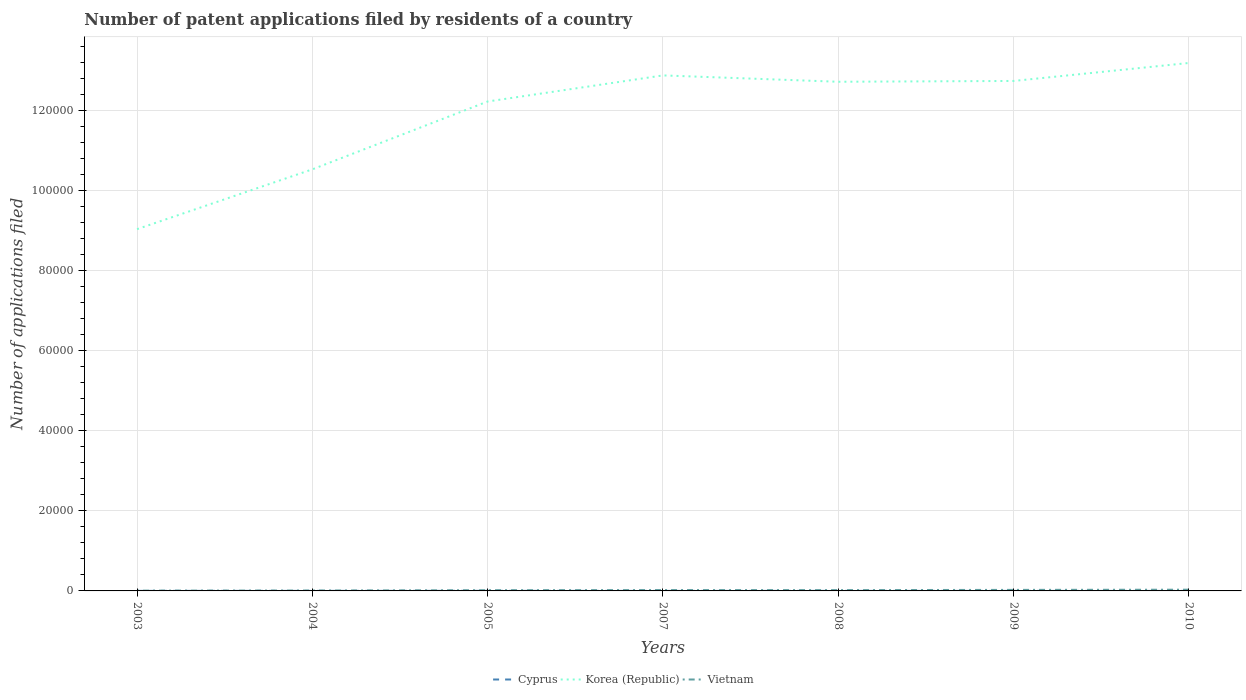Does the line corresponding to Vietnam intersect with the line corresponding to Cyprus?
Keep it short and to the point. No. Is the number of lines equal to the number of legend labels?
Ensure brevity in your answer.  Yes. Across all years, what is the maximum number of applications filed in Korea (Republic)?
Your response must be concise. 9.03e+04. What is the difference between the highest and the second highest number of applications filed in Cyprus?
Give a very brief answer. 17. What is the difference between the highest and the lowest number of applications filed in Cyprus?
Your answer should be compact. 3. How many lines are there?
Offer a terse response. 3. How are the legend labels stacked?
Provide a short and direct response. Horizontal. What is the title of the graph?
Offer a terse response. Number of patent applications filed by residents of a country. What is the label or title of the X-axis?
Your answer should be very brief. Years. What is the label or title of the Y-axis?
Make the answer very short. Number of applications filed. What is the Number of applications filed of Cyprus in 2003?
Provide a short and direct response. 12. What is the Number of applications filed of Korea (Republic) in 2003?
Give a very brief answer. 9.03e+04. What is the Number of applications filed of Cyprus in 2004?
Offer a terse response. 9. What is the Number of applications filed of Korea (Republic) in 2004?
Make the answer very short. 1.05e+05. What is the Number of applications filed in Vietnam in 2004?
Offer a terse response. 103. What is the Number of applications filed in Cyprus in 2005?
Give a very brief answer. 20. What is the Number of applications filed in Korea (Republic) in 2005?
Make the answer very short. 1.22e+05. What is the Number of applications filed of Vietnam in 2005?
Give a very brief answer. 180. What is the Number of applications filed in Cyprus in 2007?
Provide a short and direct response. 3. What is the Number of applications filed in Korea (Republic) in 2007?
Provide a short and direct response. 1.29e+05. What is the Number of applications filed in Vietnam in 2007?
Your answer should be compact. 219. What is the Number of applications filed of Cyprus in 2008?
Ensure brevity in your answer.  11. What is the Number of applications filed of Korea (Republic) in 2008?
Make the answer very short. 1.27e+05. What is the Number of applications filed in Vietnam in 2008?
Keep it short and to the point. 204. What is the Number of applications filed of Korea (Republic) in 2009?
Provide a succinct answer. 1.27e+05. What is the Number of applications filed in Vietnam in 2009?
Your answer should be compact. 258. What is the Number of applications filed of Korea (Republic) in 2010?
Your answer should be compact. 1.32e+05. What is the Number of applications filed in Vietnam in 2010?
Ensure brevity in your answer.  306. Across all years, what is the maximum Number of applications filed in Cyprus?
Your response must be concise. 20. Across all years, what is the maximum Number of applications filed of Korea (Republic)?
Provide a short and direct response. 1.32e+05. Across all years, what is the maximum Number of applications filed of Vietnam?
Give a very brief answer. 306. Across all years, what is the minimum Number of applications filed in Korea (Republic)?
Your answer should be compact. 9.03e+04. Across all years, what is the minimum Number of applications filed in Vietnam?
Offer a terse response. 78. What is the total Number of applications filed in Cyprus in the graph?
Your answer should be compact. 65. What is the total Number of applications filed in Korea (Republic) in the graph?
Ensure brevity in your answer.  8.33e+05. What is the total Number of applications filed of Vietnam in the graph?
Give a very brief answer. 1348. What is the difference between the Number of applications filed of Cyprus in 2003 and that in 2004?
Offer a terse response. 3. What is the difference between the Number of applications filed of Korea (Republic) in 2003 and that in 2004?
Offer a very short reply. -1.49e+04. What is the difference between the Number of applications filed of Korea (Republic) in 2003 and that in 2005?
Keep it short and to the point. -3.19e+04. What is the difference between the Number of applications filed of Vietnam in 2003 and that in 2005?
Give a very brief answer. -102. What is the difference between the Number of applications filed of Cyprus in 2003 and that in 2007?
Provide a short and direct response. 9. What is the difference between the Number of applications filed of Korea (Republic) in 2003 and that in 2007?
Your response must be concise. -3.84e+04. What is the difference between the Number of applications filed of Vietnam in 2003 and that in 2007?
Your answer should be compact. -141. What is the difference between the Number of applications filed of Korea (Republic) in 2003 and that in 2008?
Your answer should be very brief. -3.68e+04. What is the difference between the Number of applications filed of Vietnam in 2003 and that in 2008?
Ensure brevity in your answer.  -126. What is the difference between the Number of applications filed of Cyprus in 2003 and that in 2009?
Give a very brief answer. 6. What is the difference between the Number of applications filed in Korea (Republic) in 2003 and that in 2009?
Your answer should be very brief. -3.70e+04. What is the difference between the Number of applications filed in Vietnam in 2003 and that in 2009?
Give a very brief answer. -180. What is the difference between the Number of applications filed of Cyprus in 2003 and that in 2010?
Ensure brevity in your answer.  8. What is the difference between the Number of applications filed in Korea (Republic) in 2003 and that in 2010?
Ensure brevity in your answer.  -4.15e+04. What is the difference between the Number of applications filed in Vietnam in 2003 and that in 2010?
Provide a succinct answer. -228. What is the difference between the Number of applications filed in Korea (Republic) in 2004 and that in 2005?
Your answer should be very brief. -1.69e+04. What is the difference between the Number of applications filed in Vietnam in 2004 and that in 2005?
Give a very brief answer. -77. What is the difference between the Number of applications filed of Korea (Republic) in 2004 and that in 2007?
Ensure brevity in your answer.  -2.35e+04. What is the difference between the Number of applications filed of Vietnam in 2004 and that in 2007?
Make the answer very short. -116. What is the difference between the Number of applications filed in Korea (Republic) in 2004 and that in 2008?
Provide a succinct answer. -2.19e+04. What is the difference between the Number of applications filed of Vietnam in 2004 and that in 2008?
Your answer should be compact. -101. What is the difference between the Number of applications filed in Korea (Republic) in 2004 and that in 2009?
Provide a succinct answer. -2.21e+04. What is the difference between the Number of applications filed in Vietnam in 2004 and that in 2009?
Provide a succinct answer. -155. What is the difference between the Number of applications filed in Korea (Republic) in 2004 and that in 2010?
Give a very brief answer. -2.66e+04. What is the difference between the Number of applications filed of Vietnam in 2004 and that in 2010?
Your answer should be compact. -203. What is the difference between the Number of applications filed in Cyprus in 2005 and that in 2007?
Keep it short and to the point. 17. What is the difference between the Number of applications filed of Korea (Republic) in 2005 and that in 2007?
Your response must be concise. -6513. What is the difference between the Number of applications filed of Vietnam in 2005 and that in 2007?
Offer a very short reply. -39. What is the difference between the Number of applications filed of Korea (Republic) in 2005 and that in 2008?
Ensure brevity in your answer.  -4926. What is the difference between the Number of applications filed of Vietnam in 2005 and that in 2008?
Ensure brevity in your answer.  -24. What is the difference between the Number of applications filed of Korea (Republic) in 2005 and that in 2009?
Offer a very short reply. -5128. What is the difference between the Number of applications filed of Vietnam in 2005 and that in 2009?
Keep it short and to the point. -78. What is the difference between the Number of applications filed in Korea (Republic) in 2005 and that in 2010?
Ensure brevity in your answer.  -9617. What is the difference between the Number of applications filed of Vietnam in 2005 and that in 2010?
Offer a very short reply. -126. What is the difference between the Number of applications filed in Cyprus in 2007 and that in 2008?
Make the answer very short. -8. What is the difference between the Number of applications filed of Korea (Republic) in 2007 and that in 2008?
Your response must be concise. 1587. What is the difference between the Number of applications filed in Korea (Republic) in 2007 and that in 2009?
Provide a succinct answer. 1385. What is the difference between the Number of applications filed of Vietnam in 2007 and that in 2009?
Offer a terse response. -39. What is the difference between the Number of applications filed of Korea (Republic) in 2007 and that in 2010?
Your response must be concise. -3104. What is the difference between the Number of applications filed in Vietnam in 2007 and that in 2010?
Your response must be concise. -87. What is the difference between the Number of applications filed in Cyprus in 2008 and that in 2009?
Give a very brief answer. 5. What is the difference between the Number of applications filed of Korea (Republic) in 2008 and that in 2009?
Make the answer very short. -202. What is the difference between the Number of applications filed of Vietnam in 2008 and that in 2009?
Your answer should be very brief. -54. What is the difference between the Number of applications filed in Cyprus in 2008 and that in 2010?
Make the answer very short. 7. What is the difference between the Number of applications filed of Korea (Republic) in 2008 and that in 2010?
Ensure brevity in your answer.  -4691. What is the difference between the Number of applications filed in Vietnam in 2008 and that in 2010?
Make the answer very short. -102. What is the difference between the Number of applications filed in Cyprus in 2009 and that in 2010?
Provide a succinct answer. 2. What is the difference between the Number of applications filed of Korea (Republic) in 2009 and that in 2010?
Provide a succinct answer. -4489. What is the difference between the Number of applications filed of Vietnam in 2009 and that in 2010?
Your response must be concise. -48. What is the difference between the Number of applications filed in Cyprus in 2003 and the Number of applications filed in Korea (Republic) in 2004?
Provide a short and direct response. -1.05e+05. What is the difference between the Number of applications filed in Cyprus in 2003 and the Number of applications filed in Vietnam in 2004?
Keep it short and to the point. -91. What is the difference between the Number of applications filed in Korea (Republic) in 2003 and the Number of applications filed in Vietnam in 2004?
Your response must be concise. 9.02e+04. What is the difference between the Number of applications filed in Cyprus in 2003 and the Number of applications filed in Korea (Republic) in 2005?
Ensure brevity in your answer.  -1.22e+05. What is the difference between the Number of applications filed in Cyprus in 2003 and the Number of applications filed in Vietnam in 2005?
Provide a succinct answer. -168. What is the difference between the Number of applications filed in Korea (Republic) in 2003 and the Number of applications filed in Vietnam in 2005?
Keep it short and to the point. 9.01e+04. What is the difference between the Number of applications filed in Cyprus in 2003 and the Number of applications filed in Korea (Republic) in 2007?
Your answer should be compact. -1.29e+05. What is the difference between the Number of applications filed in Cyprus in 2003 and the Number of applications filed in Vietnam in 2007?
Your answer should be very brief. -207. What is the difference between the Number of applications filed in Korea (Republic) in 2003 and the Number of applications filed in Vietnam in 2007?
Make the answer very short. 9.01e+04. What is the difference between the Number of applications filed in Cyprus in 2003 and the Number of applications filed in Korea (Republic) in 2008?
Make the answer very short. -1.27e+05. What is the difference between the Number of applications filed of Cyprus in 2003 and the Number of applications filed of Vietnam in 2008?
Keep it short and to the point. -192. What is the difference between the Number of applications filed in Korea (Republic) in 2003 and the Number of applications filed in Vietnam in 2008?
Your answer should be very brief. 9.01e+04. What is the difference between the Number of applications filed in Cyprus in 2003 and the Number of applications filed in Korea (Republic) in 2009?
Provide a short and direct response. -1.27e+05. What is the difference between the Number of applications filed of Cyprus in 2003 and the Number of applications filed of Vietnam in 2009?
Provide a short and direct response. -246. What is the difference between the Number of applications filed in Korea (Republic) in 2003 and the Number of applications filed in Vietnam in 2009?
Offer a terse response. 9.01e+04. What is the difference between the Number of applications filed in Cyprus in 2003 and the Number of applications filed in Korea (Republic) in 2010?
Provide a succinct answer. -1.32e+05. What is the difference between the Number of applications filed in Cyprus in 2003 and the Number of applications filed in Vietnam in 2010?
Ensure brevity in your answer.  -294. What is the difference between the Number of applications filed in Korea (Republic) in 2003 and the Number of applications filed in Vietnam in 2010?
Your answer should be very brief. 9.00e+04. What is the difference between the Number of applications filed in Cyprus in 2004 and the Number of applications filed in Korea (Republic) in 2005?
Make the answer very short. -1.22e+05. What is the difference between the Number of applications filed of Cyprus in 2004 and the Number of applications filed of Vietnam in 2005?
Offer a terse response. -171. What is the difference between the Number of applications filed of Korea (Republic) in 2004 and the Number of applications filed of Vietnam in 2005?
Provide a short and direct response. 1.05e+05. What is the difference between the Number of applications filed of Cyprus in 2004 and the Number of applications filed of Korea (Republic) in 2007?
Your answer should be compact. -1.29e+05. What is the difference between the Number of applications filed of Cyprus in 2004 and the Number of applications filed of Vietnam in 2007?
Keep it short and to the point. -210. What is the difference between the Number of applications filed of Korea (Republic) in 2004 and the Number of applications filed of Vietnam in 2007?
Make the answer very short. 1.05e+05. What is the difference between the Number of applications filed in Cyprus in 2004 and the Number of applications filed in Korea (Republic) in 2008?
Ensure brevity in your answer.  -1.27e+05. What is the difference between the Number of applications filed of Cyprus in 2004 and the Number of applications filed of Vietnam in 2008?
Give a very brief answer. -195. What is the difference between the Number of applications filed of Korea (Republic) in 2004 and the Number of applications filed of Vietnam in 2008?
Your response must be concise. 1.05e+05. What is the difference between the Number of applications filed of Cyprus in 2004 and the Number of applications filed of Korea (Republic) in 2009?
Offer a very short reply. -1.27e+05. What is the difference between the Number of applications filed in Cyprus in 2004 and the Number of applications filed in Vietnam in 2009?
Your answer should be very brief. -249. What is the difference between the Number of applications filed in Korea (Republic) in 2004 and the Number of applications filed in Vietnam in 2009?
Keep it short and to the point. 1.05e+05. What is the difference between the Number of applications filed in Cyprus in 2004 and the Number of applications filed in Korea (Republic) in 2010?
Your answer should be very brief. -1.32e+05. What is the difference between the Number of applications filed in Cyprus in 2004 and the Number of applications filed in Vietnam in 2010?
Keep it short and to the point. -297. What is the difference between the Number of applications filed of Korea (Republic) in 2004 and the Number of applications filed of Vietnam in 2010?
Ensure brevity in your answer.  1.05e+05. What is the difference between the Number of applications filed in Cyprus in 2005 and the Number of applications filed in Korea (Republic) in 2007?
Provide a short and direct response. -1.29e+05. What is the difference between the Number of applications filed in Cyprus in 2005 and the Number of applications filed in Vietnam in 2007?
Your response must be concise. -199. What is the difference between the Number of applications filed of Korea (Republic) in 2005 and the Number of applications filed of Vietnam in 2007?
Keep it short and to the point. 1.22e+05. What is the difference between the Number of applications filed in Cyprus in 2005 and the Number of applications filed in Korea (Republic) in 2008?
Make the answer very short. -1.27e+05. What is the difference between the Number of applications filed in Cyprus in 2005 and the Number of applications filed in Vietnam in 2008?
Your answer should be very brief. -184. What is the difference between the Number of applications filed of Korea (Republic) in 2005 and the Number of applications filed of Vietnam in 2008?
Make the answer very short. 1.22e+05. What is the difference between the Number of applications filed of Cyprus in 2005 and the Number of applications filed of Korea (Republic) in 2009?
Your answer should be compact. -1.27e+05. What is the difference between the Number of applications filed of Cyprus in 2005 and the Number of applications filed of Vietnam in 2009?
Keep it short and to the point. -238. What is the difference between the Number of applications filed of Korea (Republic) in 2005 and the Number of applications filed of Vietnam in 2009?
Offer a terse response. 1.22e+05. What is the difference between the Number of applications filed of Cyprus in 2005 and the Number of applications filed of Korea (Republic) in 2010?
Provide a short and direct response. -1.32e+05. What is the difference between the Number of applications filed in Cyprus in 2005 and the Number of applications filed in Vietnam in 2010?
Ensure brevity in your answer.  -286. What is the difference between the Number of applications filed in Korea (Republic) in 2005 and the Number of applications filed in Vietnam in 2010?
Your answer should be very brief. 1.22e+05. What is the difference between the Number of applications filed of Cyprus in 2007 and the Number of applications filed of Korea (Republic) in 2008?
Keep it short and to the point. -1.27e+05. What is the difference between the Number of applications filed in Cyprus in 2007 and the Number of applications filed in Vietnam in 2008?
Give a very brief answer. -201. What is the difference between the Number of applications filed of Korea (Republic) in 2007 and the Number of applications filed of Vietnam in 2008?
Make the answer very short. 1.28e+05. What is the difference between the Number of applications filed of Cyprus in 2007 and the Number of applications filed of Korea (Republic) in 2009?
Your answer should be very brief. -1.27e+05. What is the difference between the Number of applications filed in Cyprus in 2007 and the Number of applications filed in Vietnam in 2009?
Make the answer very short. -255. What is the difference between the Number of applications filed in Korea (Republic) in 2007 and the Number of applications filed in Vietnam in 2009?
Your answer should be compact. 1.28e+05. What is the difference between the Number of applications filed in Cyprus in 2007 and the Number of applications filed in Korea (Republic) in 2010?
Provide a short and direct response. -1.32e+05. What is the difference between the Number of applications filed in Cyprus in 2007 and the Number of applications filed in Vietnam in 2010?
Ensure brevity in your answer.  -303. What is the difference between the Number of applications filed of Korea (Republic) in 2007 and the Number of applications filed of Vietnam in 2010?
Give a very brief answer. 1.28e+05. What is the difference between the Number of applications filed of Cyprus in 2008 and the Number of applications filed of Korea (Republic) in 2009?
Provide a short and direct response. -1.27e+05. What is the difference between the Number of applications filed of Cyprus in 2008 and the Number of applications filed of Vietnam in 2009?
Provide a short and direct response. -247. What is the difference between the Number of applications filed in Korea (Republic) in 2008 and the Number of applications filed in Vietnam in 2009?
Make the answer very short. 1.27e+05. What is the difference between the Number of applications filed in Cyprus in 2008 and the Number of applications filed in Korea (Republic) in 2010?
Your response must be concise. -1.32e+05. What is the difference between the Number of applications filed of Cyprus in 2008 and the Number of applications filed of Vietnam in 2010?
Your answer should be very brief. -295. What is the difference between the Number of applications filed of Korea (Republic) in 2008 and the Number of applications filed of Vietnam in 2010?
Ensure brevity in your answer.  1.27e+05. What is the difference between the Number of applications filed of Cyprus in 2009 and the Number of applications filed of Korea (Republic) in 2010?
Make the answer very short. -1.32e+05. What is the difference between the Number of applications filed in Cyprus in 2009 and the Number of applications filed in Vietnam in 2010?
Ensure brevity in your answer.  -300. What is the difference between the Number of applications filed in Korea (Republic) in 2009 and the Number of applications filed in Vietnam in 2010?
Keep it short and to the point. 1.27e+05. What is the average Number of applications filed in Cyprus per year?
Ensure brevity in your answer.  9.29. What is the average Number of applications filed of Korea (Republic) per year?
Your answer should be very brief. 1.19e+05. What is the average Number of applications filed of Vietnam per year?
Provide a short and direct response. 192.57. In the year 2003, what is the difference between the Number of applications filed in Cyprus and Number of applications filed in Korea (Republic)?
Keep it short and to the point. -9.03e+04. In the year 2003, what is the difference between the Number of applications filed of Cyprus and Number of applications filed of Vietnam?
Give a very brief answer. -66. In the year 2003, what is the difference between the Number of applications filed in Korea (Republic) and Number of applications filed in Vietnam?
Keep it short and to the point. 9.02e+04. In the year 2004, what is the difference between the Number of applications filed of Cyprus and Number of applications filed of Korea (Republic)?
Offer a terse response. -1.05e+05. In the year 2004, what is the difference between the Number of applications filed in Cyprus and Number of applications filed in Vietnam?
Your answer should be very brief. -94. In the year 2004, what is the difference between the Number of applications filed in Korea (Republic) and Number of applications filed in Vietnam?
Give a very brief answer. 1.05e+05. In the year 2005, what is the difference between the Number of applications filed in Cyprus and Number of applications filed in Korea (Republic)?
Offer a terse response. -1.22e+05. In the year 2005, what is the difference between the Number of applications filed of Cyprus and Number of applications filed of Vietnam?
Offer a very short reply. -160. In the year 2005, what is the difference between the Number of applications filed in Korea (Republic) and Number of applications filed in Vietnam?
Keep it short and to the point. 1.22e+05. In the year 2007, what is the difference between the Number of applications filed of Cyprus and Number of applications filed of Korea (Republic)?
Your response must be concise. -1.29e+05. In the year 2007, what is the difference between the Number of applications filed in Cyprus and Number of applications filed in Vietnam?
Offer a terse response. -216. In the year 2007, what is the difference between the Number of applications filed of Korea (Republic) and Number of applications filed of Vietnam?
Offer a very short reply. 1.28e+05. In the year 2008, what is the difference between the Number of applications filed in Cyprus and Number of applications filed in Korea (Republic)?
Provide a short and direct response. -1.27e+05. In the year 2008, what is the difference between the Number of applications filed of Cyprus and Number of applications filed of Vietnam?
Keep it short and to the point. -193. In the year 2008, what is the difference between the Number of applications filed in Korea (Republic) and Number of applications filed in Vietnam?
Your answer should be compact. 1.27e+05. In the year 2009, what is the difference between the Number of applications filed in Cyprus and Number of applications filed in Korea (Republic)?
Provide a succinct answer. -1.27e+05. In the year 2009, what is the difference between the Number of applications filed of Cyprus and Number of applications filed of Vietnam?
Make the answer very short. -252. In the year 2009, what is the difference between the Number of applications filed in Korea (Republic) and Number of applications filed in Vietnam?
Your answer should be compact. 1.27e+05. In the year 2010, what is the difference between the Number of applications filed in Cyprus and Number of applications filed in Korea (Republic)?
Your answer should be very brief. -1.32e+05. In the year 2010, what is the difference between the Number of applications filed of Cyprus and Number of applications filed of Vietnam?
Provide a short and direct response. -302. In the year 2010, what is the difference between the Number of applications filed of Korea (Republic) and Number of applications filed of Vietnam?
Provide a short and direct response. 1.31e+05. What is the ratio of the Number of applications filed of Cyprus in 2003 to that in 2004?
Provide a short and direct response. 1.33. What is the ratio of the Number of applications filed in Korea (Republic) in 2003 to that in 2004?
Make the answer very short. 0.86. What is the ratio of the Number of applications filed in Vietnam in 2003 to that in 2004?
Provide a short and direct response. 0.76. What is the ratio of the Number of applications filed in Korea (Republic) in 2003 to that in 2005?
Your answer should be very brief. 0.74. What is the ratio of the Number of applications filed in Vietnam in 2003 to that in 2005?
Provide a short and direct response. 0.43. What is the ratio of the Number of applications filed in Cyprus in 2003 to that in 2007?
Your response must be concise. 4. What is the ratio of the Number of applications filed of Korea (Republic) in 2003 to that in 2007?
Your response must be concise. 0.7. What is the ratio of the Number of applications filed of Vietnam in 2003 to that in 2007?
Your answer should be compact. 0.36. What is the ratio of the Number of applications filed in Korea (Republic) in 2003 to that in 2008?
Provide a short and direct response. 0.71. What is the ratio of the Number of applications filed in Vietnam in 2003 to that in 2008?
Your answer should be very brief. 0.38. What is the ratio of the Number of applications filed of Korea (Republic) in 2003 to that in 2009?
Provide a succinct answer. 0.71. What is the ratio of the Number of applications filed of Vietnam in 2003 to that in 2009?
Give a very brief answer. 0.3. What is the ratio of the Number of applications filed in Korea (Republic) in 2003 to that in 2010?
Your answer should be very brief. 0.69. What is the ratio of the Number of applications filed in Vietnam in 2003 to that in 2010?
Give a very brief answer. 0.25. What is the ratio of the Number of applications filed in Cyprus in 2004 to that in 2005?
Your response must be concise. 0.45. What is the ratio of the Number of applications filed in Korea (Republic) in 2004 to that in 2005?
Ensure brevity in your answer.  0.86. What is the ratio of the Number of applications filed in Vietnam in 2004 to that in 2005?
Keep it short and to the point. 0.57. What is the ratio of the Number of applications filed of Korea (Republic) in 2004 to that in 2007?
Offer a very short reply. 0.82. What is the ratio of the Number of applications filed in Vietnam in 2004 to that in 2007?
Make the answer very short. 0.47. What is the ratio of the Number of applications filed of Cyprus in 2004 to that in 2008?
Ensure brevity in your answer.  0.82. What is the ratio of the Number of applications filed in Korea (Republic) in 2004 to that in 2008?
Offer a very short reply. 0.83. What is the ratio of the Number of applications filed of Vietnam in 2004 to that in 2008?
Your response must be concise. 0.5. What is the ratio of the Number of applications filed of Korea (Republic) in 2004 to that in 2009?
Offer a very short reply. 0.83. What is the ratio of the Number of applications filed of Vietnam in 2004 to that in 2009?
Your answer should be very brief. 0.4. What is the ratio of the Number of applications filed in Cyprus in 2004 to that in 2010?
Provide a succinct answer. 2.25. What is the ratio of the Number of applications filed in Korea (Republic) in 2004 to that in 2010?
Your response must be concise. 0.8. What is the ratio of the Number of applications filed in Vietnam in 2004 to that in 2010?
Give a very brief answer. 0.34. What is the ratio of the Number of applications filed in Korea (Republic) in 2005 to that in 2007?
Your response must be concise. 0.95. What is the ratio of the Number of applications filed in Vietnam in 2005 to that in 2007?
Give a very brief answer. 0.82. What is the ratio of the Number of applications filed in Cyprus in 2005 to that in 2008?
Your response must be concise. 1.82. What is the ratio of the Number of applications filed of Korea (Republic) in 2005 to that in 2008?
Offer a terse response. 0.96. What is the ratio of the Number of applications filed of Vietnam in 2005 to that in 2008?
Offer a terse response. 0.88. What is the ratio of the Number of applications filed in Korea (Republic) in 2005 to that in 2009?
Your answer should be compact. 0.96. What is the ratio of the Number of applications filed in Vietnam in 2005 to that in 2009?
Ensure brevity in your answer.  0.7. What is the ratio of the Number of applications filed of Korea (Republic) in 2005 to that in 2010?
Offer a very short reply. 0.93. What is the ratio of the Number of applications filed of Vietnam in 2005 to that in 2010?
Make the answer very short. 0.59. What is the ratio of the Number of applications filed in Cyprus in 2007 to that in 2008?
Provide a short and direct response. 0.27. What is the ratio of the Number of applications filed in Korea (Republic) in 2007 to that in 2008?
Keep it short and to the point. 1.01. What is the ratio of the Number of applications filed of Vietnam in 2007 to that in 2008?
Provide a succinct answer. 1.07. What is the ratio of the Number of applications filed of Cyprus in 2007 to that in 2009?
Make the answer very short. 0.5. What is the ratio of the Number of applications filed in Korea (Republic) in 2007 to that in 2009?
Provide a short and direct response. 1.01. What is the ratio of the Number of applications filed in Vietnam in 2007 to that in 2009?
Make the answer very short. 0.85. What is the ratio of the Number of applications filed of Korea (Republic) in 2007 to that in 2010?
Provide a short and direct response. 0.98. What is the ratio of the Number of applications filed in Vietnam in 2007 to that in 2010?
Your answer should be very brief. 0.72. What is the ratio of the Number of applications filed in Cyprus in 2008 to that in 2009?
Keep it short and to the point. 1.83. What is the ratio of the Number of applications filed of Korea (Republic) in 2008 to that in 2009?
Your answer should be compact. 1. What is the ratio of the Number of applications filed of Vietnam in 2008 to that in 2009?
Offer a very short reply. 0.79. What is the ratio of the Number of applications filed in Cyprus in 2008 to that in 2010?
Your answer should be compact. 2.75. What is the ratio of the Number of applications filed of Korea (Republic) in 2008 to that in 2010?
Keep it short and to the point. 0.96. What is the ratio of the Number of applications filed of Vietnam in 2008 to that in 2010?
Provide a short and direct response. 0.67. What is the ratio of the Number of applications filed in Korea (Republic) in 2009 to that in 2010?
Offer a very short reply. 0.97. What is the ratio of the Number of applications filed in Vietnam in 2009 to that in 2010?
Your answer should be very brief. 0.84. What is the difference between the highest and the second highest Number of applications filed of Korea (Republic)?
Your answer should be compact. 3104. What is the difference between the highest and the lowest Number of applications filed of Korea (Republic)?
Provide a short and direct response. 4.15e+04. What is the difference between the highest and the lowest Number of applications filed of Vietnam?
Keep it short and to the point. 228. 